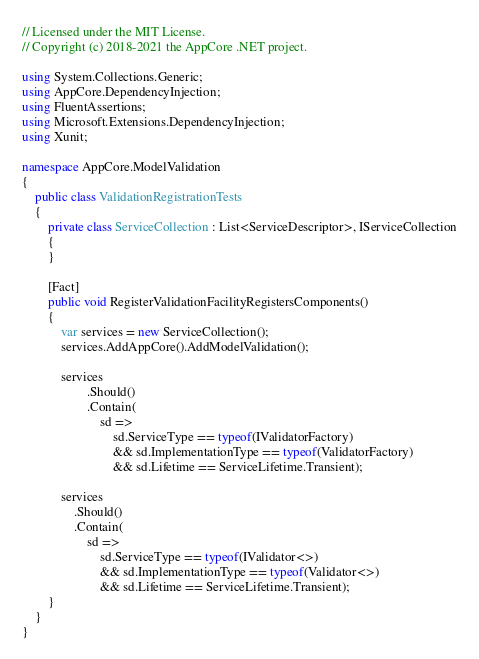<code> <loc_0><loc_0><loc_500><loc_500><_C#_>// Licensed under the MIT License.
// Copyright (c) 2018-2021 the AppCore .NET project.

using System.Collections.Generic;
using AppCore.DependencyInjection;
using FluentAssertions;
using Microsoft.Extensions.DependencyInjection;
using Xunit;

namespace AppCore.ModelValidation
{
    public class ValidationRegistrationTests
    {
        private class ServiceCollection : List<ServiceDescriptor>, IServiceCollection
        {
        }

        [Fact]
        public void RegisterValidationFacilityRegistersComponents()
        {
            var services = new ServiceCollection();
            services.AddAppCore().AddModelValidation();

            services
                    .Should()
                    .Contain(
                        sd =>
                            sd.ServiceType == typeof(IValidatorFactory)
                            && sd.ImplementationType == typeof(ValidatorFactory)
                            && sd.Lifetime == ServiceLifetime.Transient);

            services
                .Should()
                .Contain(
                    sd =>
                        sd.ServiceType == typeof(IValidator<>)
                        && sd.ImplementationType == typeof(Validator<>)
                        && sd.Lifetime == ServiceLifetime.Transient);
        }
    }
}</code> 